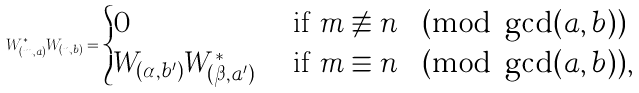<formula> <loc_0><loc_0><loc_500><loc_500>W _ { ( m , a ) } ^ { * } W _ { ( n , b ) } = \begin{cases} 0 & \text { if } m \not \equiv n \pmod { \gcd ( a , b ) } \\ W _ { ( \alpha , b ^ { \prime } ) } W _ { ( \beta , a ^ { \prime } ) } ^ { * } & \text { if } m \equiv n \pmod { \gcd ( a , b ) } , \end{cases}</formula> 